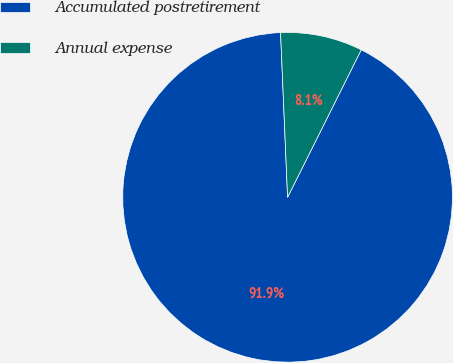<chart> <loc_0><loc_0><loc_500><loc_500><pie_chart><fcel>Accumulated postretirement<fcel>Annual expense<nl><fcel>91.95%<fcel>8.05%<nl></chart> 